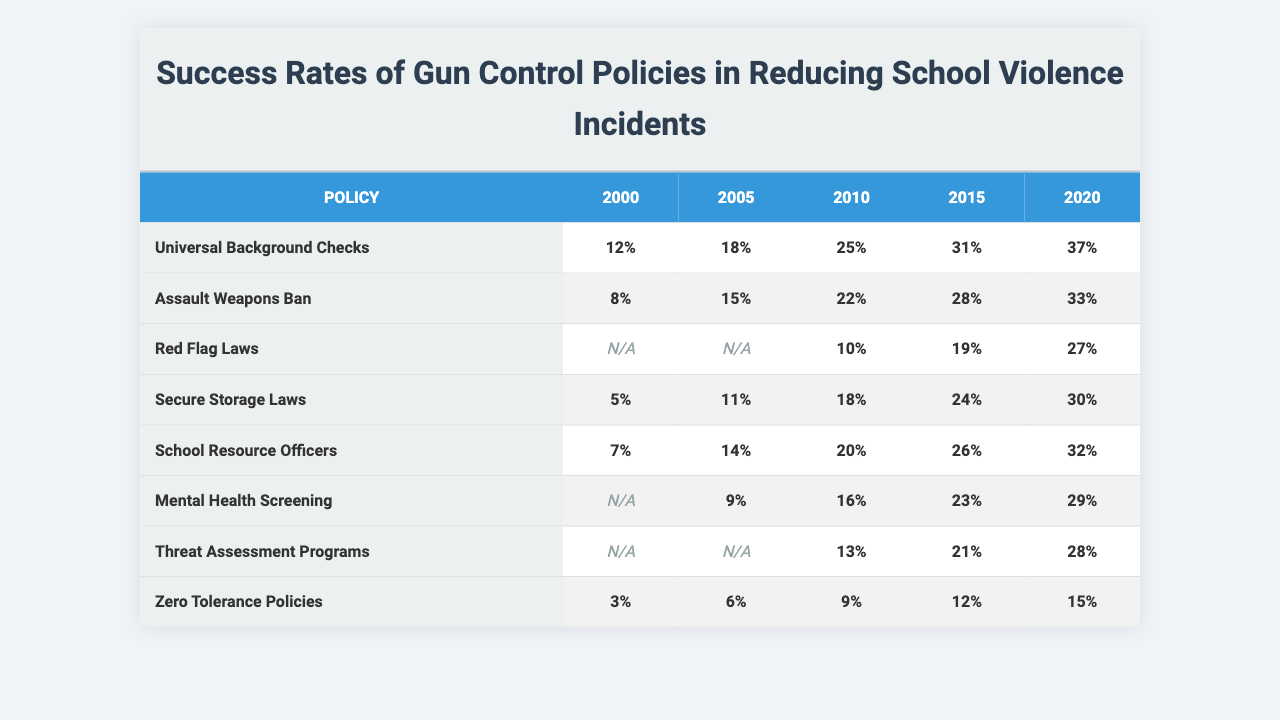What is the success rate of Universal Background Checks in 2020? The success rate for Universal Background Checks is directly found in the table under the 2020 column, which shows a value of 37%.
Answer: 37% What is the highest success rate among all policies in 2015? By checking the success rates in the 2015 column for each policy, the highest value is 31%, which corresponds to Universal Background Checks.
Answer: 31% Are there any policies with no recorded success rates in any year? By examining the table, some policies have null values for certain years but no policies have no recorded success rates at all times.
Answer: No What is the success rate difference between the Assault Weapons Ban in 2010 and 2020? The 2010 success rate for the Assault Weapons Ban is 22%, and for 2020 it is 33%. The difference is calculated as 33% - 22% = 11%.
Answer: 11% Which policies show an improvement in success rates from 2000 to 2020? Looking across the years for each policy, Universal Background Checks, Assault Weapons Ban, Secure Storage Laws, School Resource Officers, Mental Health Screening, and Threat Assessment Programs all show an increase from 2000 to 2020.
Answer: 6 What's the average success rate for Red Flag Laws over the years listed? The success rates for Red Flag Laws that are available are 10%, 19%, and 27%. The average is calculated as (10 + 19 + 27) / 3 = 18.67%, which can be rounded to 19%.
Answer: 19% Which policy had the lowest success rate in 2005? By scanning the 2005 column, the policy with the lowest success rate is Zero Tolerance Policies at 6%.
Answer: 6% What is the average success rate for Secure Storage Laws from 2000 to 2020? The success rates for Secure Storage Laws in the specified years are 5%, 11%, 18%, 24%, and 30%. The average calculation is (5 + 11 + 18 + 24 + 30) / 5 = 17.6%, which rounds to 18%.
Answer: 18% Is it true that Zero Tolerance Policies have an increasing success rate? When observing the success rates for Zero Tolerance Policies across the years, they are 3%, 6%, 9%, 12%, and 15%, which shows a consistent increase.
Answer: Yes What is the success rate of School Resource Officers in 2010? The success rate for School Resource Officers in 2010 is noted in the table as 20%.
Answer: 20% What is the difference in success rates between Mental Health Screening and Threat Assessment Programs in 2015? The values for Mental Health Screening and Threat Assessment Programs in 2015 are 23% and 21% respectively. The difference calculated is 23% - 21% = 2%.
Answer: 2% 